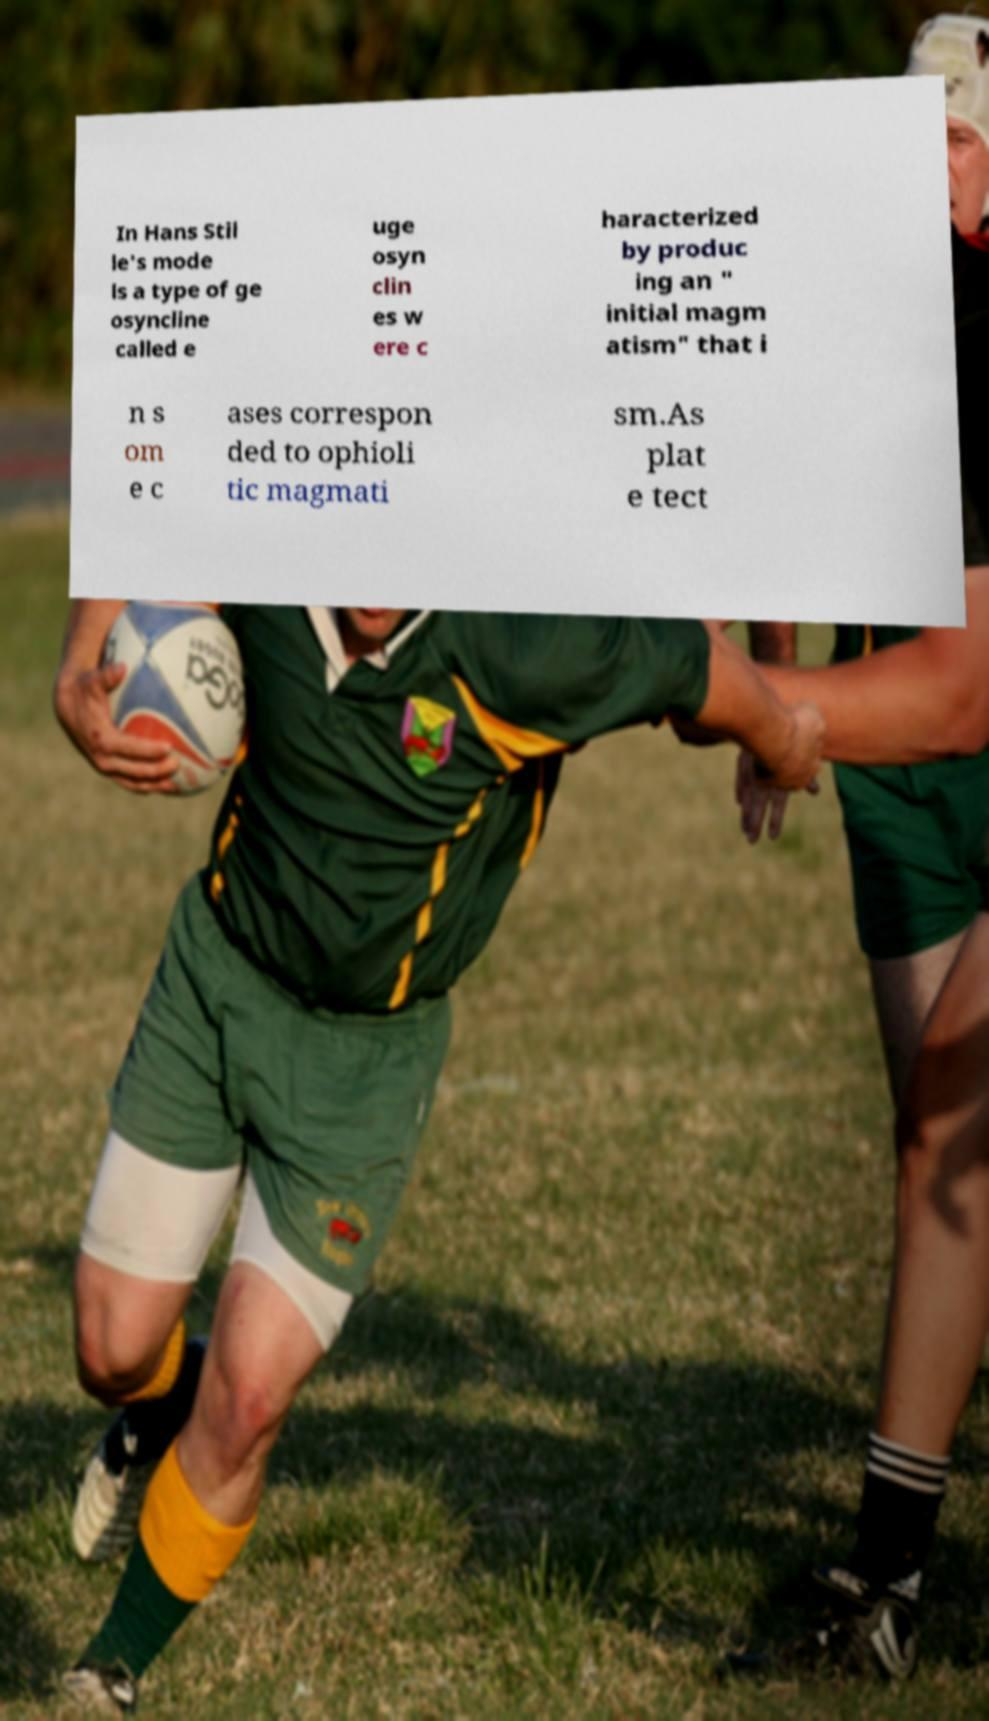Please identify and transcribe the text found in this image. In Hans Stil le's mode ls a type of ge osyncline called e uge osyn clin es w ere c haracterized by produc ing an " initial magm atism" that i n s om e c ases correspon ded to ophioli tic magmati sm.As plat e tect 